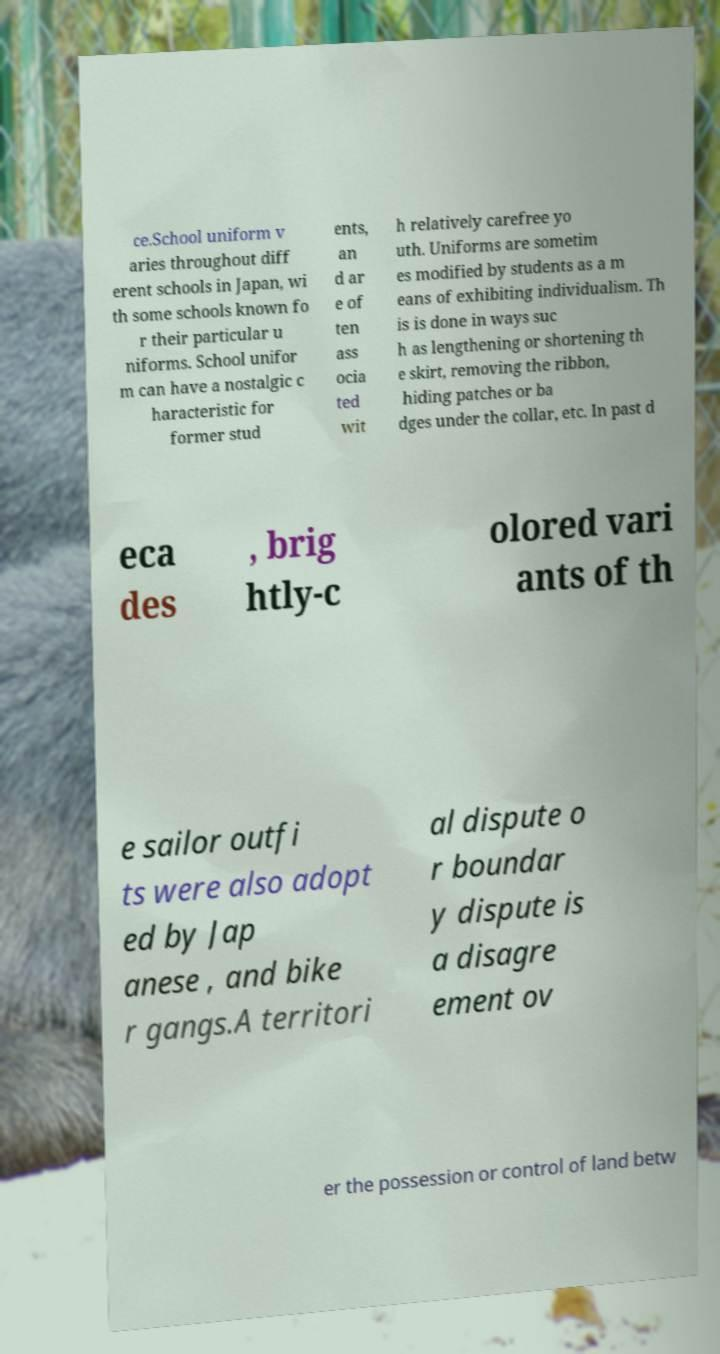Can you read and provide the text displayed in the image?This photo seems to have some interesting text. Can you extract and type it out for me? ce.School uniform v aries throughout diff erent schools in Japan, wi th some schools known fo r their particular u niforms. School unifor m can have a nostalgic c haracteristic for former stud ents, an d ar e of ten ass ocia ted wit h relatively carefree yo uth. Uniforms are sometim es modified by students as a m eans of exhibiting individualism. Th is is done in ways suc h as lengthening or shortening th e skirt, removing the ribbon, hiding patches or ba dges under the collar, etc. In past d eca des , brig htly-c olored vari ants of th e sailor outfi ts were also adopt ed by Jap anese , and bike r gangs.A territori al dispute o r boundar y dispute is a disagre ement ov er the possession or control of land betw 